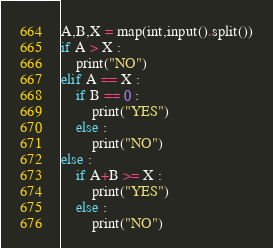Convert code to text. <code><loc_0><loc_0><loc_500><loc_500><_Python_>A,B,X = map(int,input().split())
if A > X :
    print("NO")
elif A == X :
    if B == 0 :
        print("YES")
    else :
        print("NO")
else :
    if A+B >= X :
        print("YES")
    else :
        print("NO")

</code> 